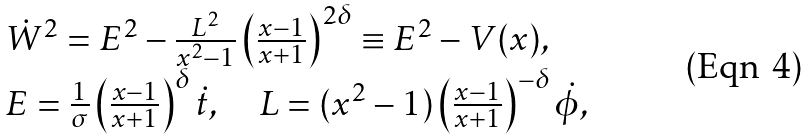Convert formula to latex. <formula><loc_0><loc_0><loc_500><loc_500>\begin{array} { l } \dot { W } ^ { 2 } = E ^ { 2 } - \frac { L ^ { 2 } } { x ^ { 2 } - 1 } \left ( \frac { x - 1 } { x + 1 } \right ) ^ { 2 \delta } \equiv E ^ { 2 } - V ( x ) , \\ E = \frac { 1 } { \sigma } \left ( \frac { x - 1 } { x + 1 } \right ) ^ { \delta } \dot { t } , \quad L = ( x ^ { 2 } - 1 ) \left ( \frac { x - 1 } { x + 1 } \right ) ^ { - \delta } \dot { \phi } , \end{array}</formula> 